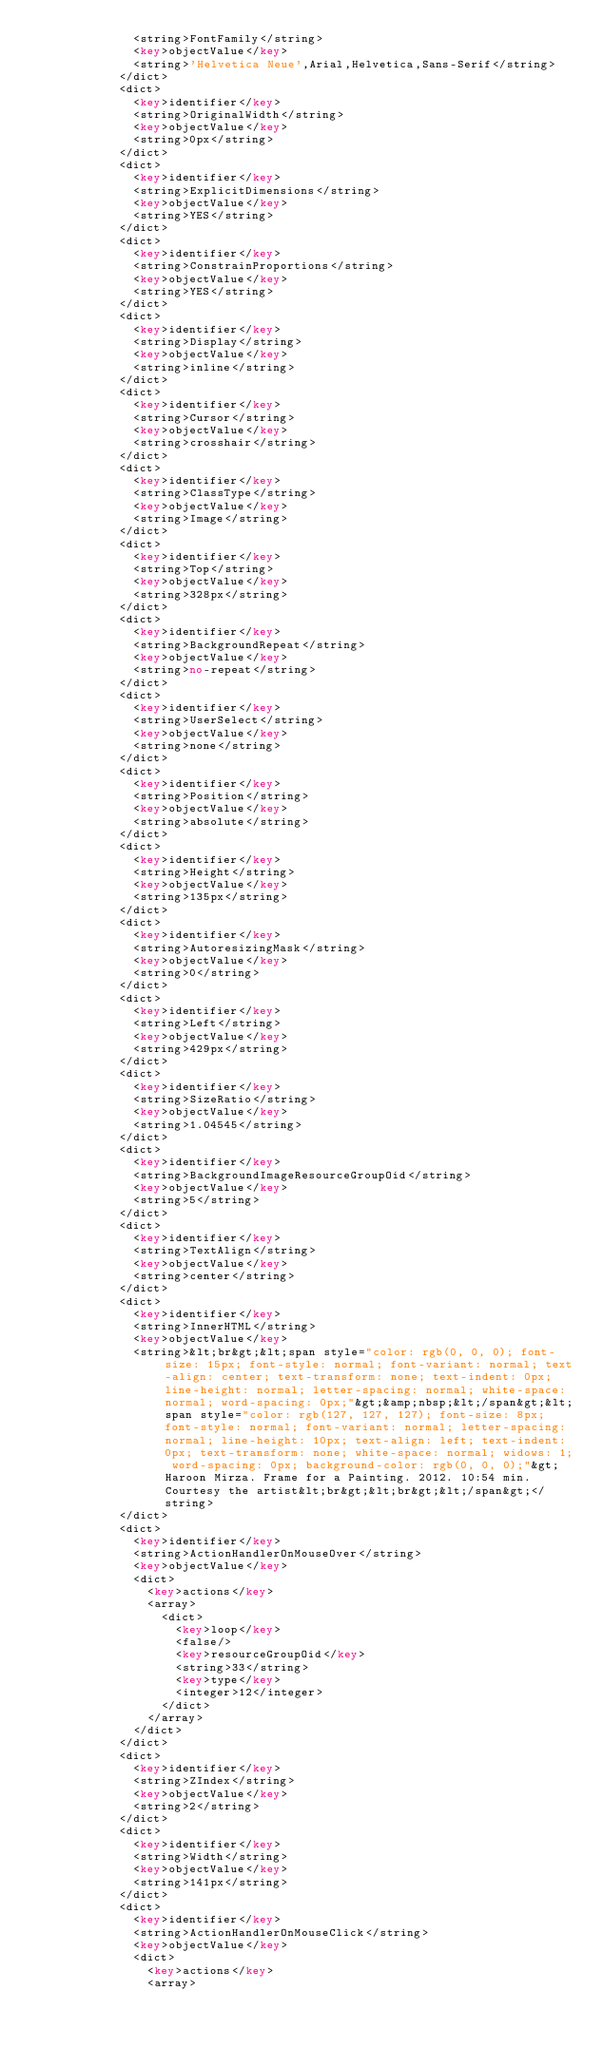Convert code to text. <code><loc_0><loc_0><loc_500><loc_500><_XML_>							<string>FontFamily</string>
							<key>objectValue</key>
							<string>'Helvetica Neue',Arial,Helvetica,Sans-Serif</string>
						</dict>
						<dict>
							<key>identifier</key>
							<string>OriginalWidth</string>
							<key>objectValue</key>
							<string>0px</string>
						</dict>
						<dict>
							<key>identifier</key>
							<string>ExplicitDimensions</string>
							<key>objectValue</key>
							<string>YES</string>
						</dict>
						<dict>
							<key>identifier</key>
							<string>ConstrainProportions</string>
							<key>objectValue</key>
							<string>YES</string>
						</dict>
						<dict>
							<key>identifier</key>
							<string>Display</string>
							<key>objectValue</key>
							<string>inline</string>
						</dict>
						<dict>
							<key>identifier</key>
							<string>Cursor</string>
							<key>objectValue</key>
							<string>crosshair</string>
						</dict>
						<dict>
							<key>identifier</key>
							<string>ClassType</string>
							<key>objectValue</key>
							<string>Image</string>
						</dict>
						<dict>
							<key>identifier</key>
							<string>Top</string>
							<key>objectValue</key>
							<string>328px</string>
						</dict>
						<dict>
							<key>identifier</key>
							<string>BackgroundRepeat</string>
							<key>objectValue</key>
							<string>no-repeat</string>
						</dict>
						<dict>
							<key>identifier</key>
							<string>UserSelect</string>
							<key>objectValue</key>
							<string>none</string>
						</dict>
						<dict>
							<key>identifier</key>
							<string>Position</string>
							<key>objectValue</key>
							<string>absolute</string>
						</dict>
						<dict>
							<key>identifier</key>
							<string>Height</string>
							<key>objectValue</key>
							<string>135px</string>
						</dict>
						<dict>
							<key>identifier</key>
							<string>AutoresizingMask</string>
							<key>objectValue</key>
							<string>0</string>
						</dict>
						<dict>
							<key>identifier</key>
							<string>Left</string>
							<key>objectValue</key>
							<string>429px</string>
						</dict>
						<dict>
							<key>identifier</key>
							<string>SizeRatio</string>
							<key>objectValue</key>
							<string>1.04545</string>
						</dict>
						<dict>
							<key>identifier</key>
							<string>BackgroundImageResourceGroupOid</string>
							<key>objectValue</key>
							<string>5</string>
						</dict>
						<dict>
							<key>identifier</key>
							<string>TextAlign</string>
							<key>objectValue</key>
							<string>center</string>
						</dict>
						<dict>
							<key>identifier</key>
							<string>InnerHTML</string>
							<key>objectValue</key>
							<string>&lt;br&gt;&lt;span style="color: rgb(0, 0, 0); font-size: 15px; font-style: normal; font-variant: normal; text-align: center; text-transform: none; text-indent: 0px; line-height: normal; letter-spacing: normal; white-space: normal; word-spacing: 0px;"&gt;&amp;nbsp;&lt;/span&gt;&lt;span style="color: rgb(127, 127, 127); font-size: 8px; font-style: normal; font-variant: normal; letter-spacing: normal; line-height: 10px; text-align: left; text-indent: 0px; text-transform: none; white-space: normal; widows: 1; word-spacing: 0px; background-color: rgb(0, 0, 0);"&gt;Haroon Mirza. Frame for a Painting. 2012. 10:54 min. Courtesy the artist&lt;br&gt;&lt;br&gt;&lt;/span&gt;</string>
						</dict>
						<dict>
							<key>identifier</key>
							<string>ActionHandlerOnMouseOver</string>
							<key>objectValue</key>
							<dict>
								<key>actions</key>
								<array>
									<dict>
										<key>loop</key>
										<false/>
										<key>resourceGroupOid</key>
										<string>33</string>
										<key>type</key>
										<integer>12</integer>
									</dict>
								</array>
							</dict>
						</dict>
						<dict>
							<key>identifier</key>
							<string>ZIndex</string>
							<key>objectValue</key>
							<string>2</string>
						</dict>
						<dict>
							<key>identifier</key>
							<string>Width</string>
							<key>objectValue</key>
							<string>141px</string>
						</dict>
						<dict>
							<key>identifier</key>
							<string>ActionHandlerOnMouseClick</string>
							<key>objectValue</key>
							<dict>
								<key>actions</key>
								<array></code> 